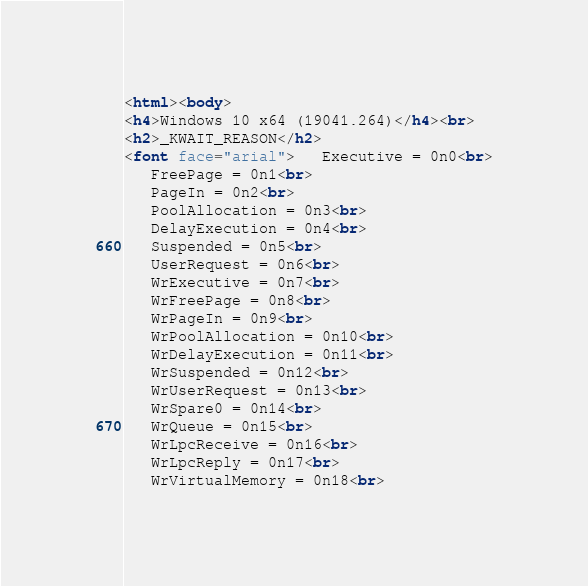<code> <loc_0><loc_0><loc_500><loc_500><_HTML_><html><body>
<h4>Windows 10 x64 (19041.264)</h4><br>
<h2>_KWAIT_REASON</h2>
<font face="arial">   Executive = 0n0<br>
   FreePage = 0n1<br>
   PageIn = 0n2<br>
   PoolAllocation = 0n3<br>
   DelayExecution = 0n4<br>
   Suspended = 0n5<br>
   UserRequest = 0n6<br>
   WrExecutive = 0n7<br>
   WrFreePage = 0n8<br>
   WrPageIn = 0n9<br>
   WrPoolAllocation = 0n10<br>
   WrDelayExecution = 0n11<br>
   WrSuspended = 0n12<br>
   WrUserRequest = 0n13<br>
   WrSpare0 = 0n14<br>
   WrQueue = 0n15<br>
   WrLpcReceive = 0n16<br>
   WrLpcReply = 0n17<br>
   WrVirtualMemory = 0n18<br></code> 